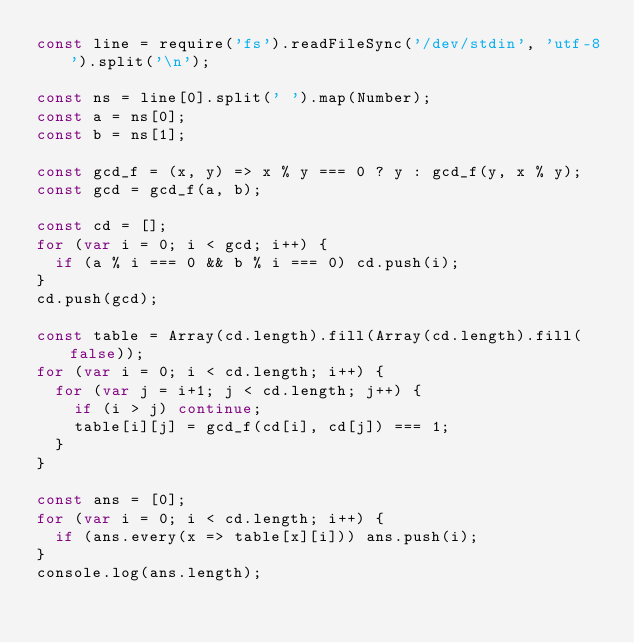<code> <loc_0><loc_0><loc_500><loc_500><_JavaScript_>const line = require('fs').readFileSync('/dev/stdin', 'utf-8').split('\n');

const ns = line[0].split(' ').map(Number);
const a = ns[0];
const b = ns[1];

const gcd_f = (x, y) => x % y === 0 ? y : gcd_f(y, x % y);
const gcd = gcd_f(a, b);

const cd = [];
for (var i = 0; i < gcd; i++) {
  if (a % i === 0 && b % i === 0) cd.push(i);
}
cd.push(gcd);

const table = Array(cd.length).fill(Array(cd.length).fill(false));
for (var i = 0; i < cd.length; i++) {
  for (var j = i+1; j < cd.length; j++) {
    if (i > j) continue;
    table[i][j] = gcd_f(cd[i], cd[j]) === 1;
  }
}

const ans = [0];
for (var i = 0; i < cd.length; i++) {
  if (ans.every(x => table[x][i])) ans.push(i);
}
console.log(ans.length);
</code> 